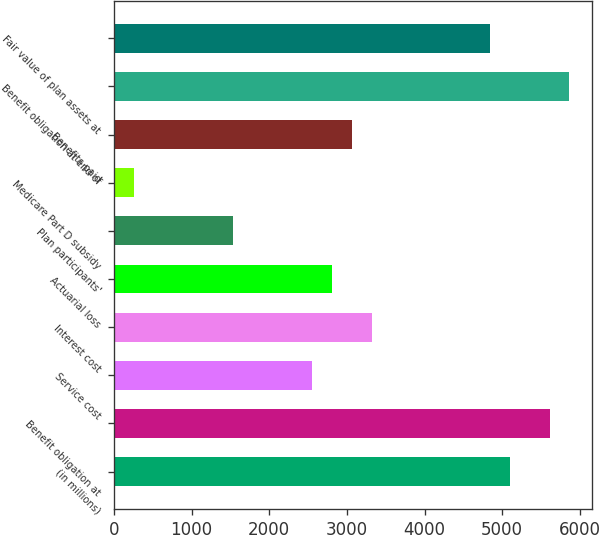Convert chart to OTSL. <chart><loc_0><loc_0><loc_500><loc_500><bar_chart><fcel>(in millions)<fcel>Benefit obligation at<fcel>Service cost<fcel>Interest cost<fcel>Actuarial loss<fcel>Plan participants'<fcel>Medicare Part D subsidy<fcel>Benefits paid<fcel>Benefit obligation at end of<fcel>Fair value of plan assets at<nl><fcel>5101.26<fcel>5610.91<fcel>2553.01<fcel>3317.48<fcel>2807.84<fcel>1533.71<fcel>259.58<fcel>3062.66<fcel>5865.73<fcel>4846.43<nl></chart> 